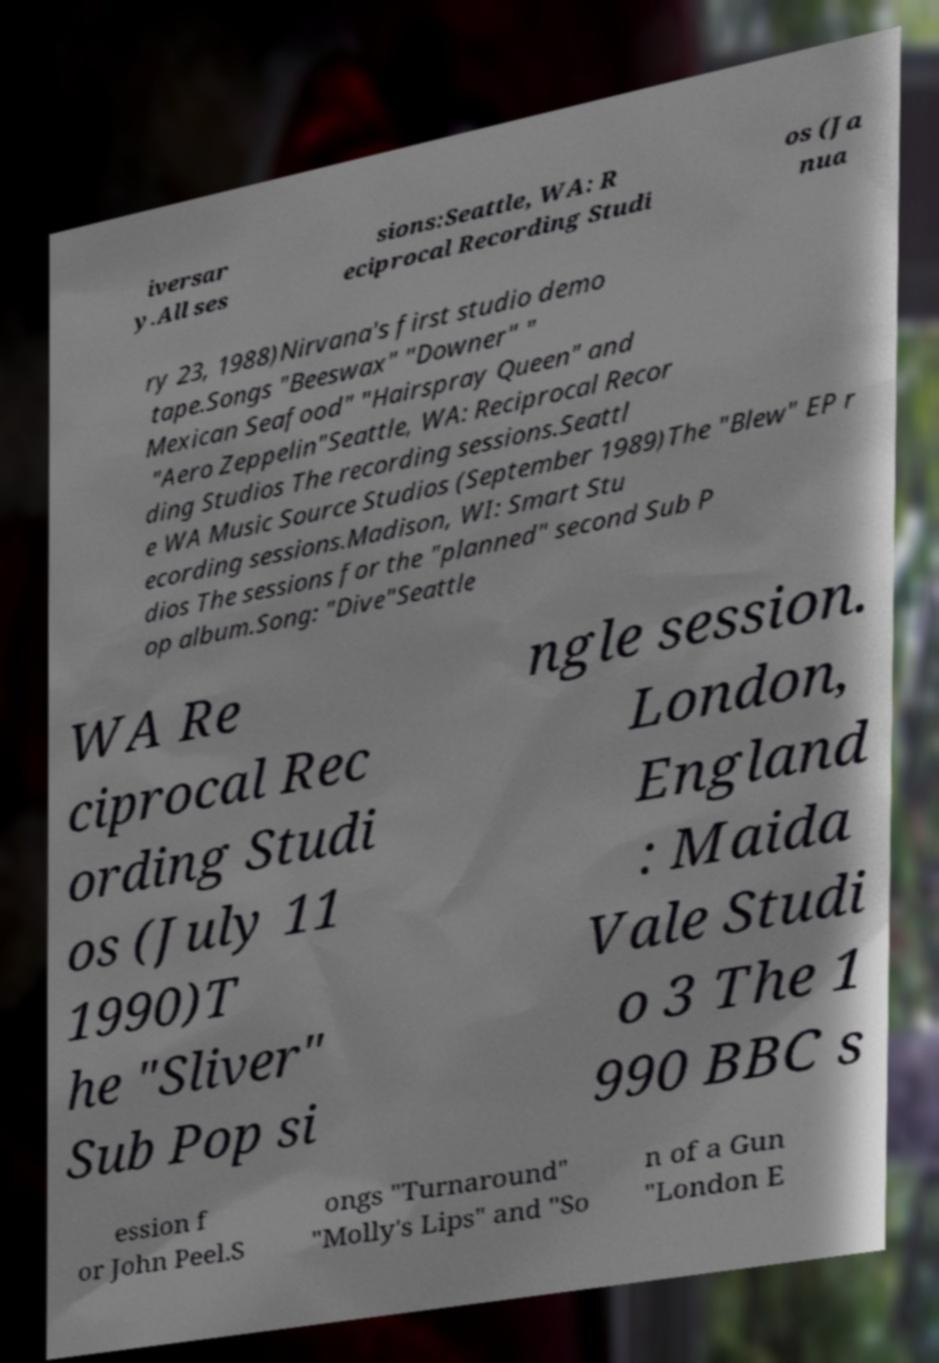I need the written content from this picture converted into text. Can you do that? iversar y.All ses sions:Seattle, WA: R eciprocal Recording Studi os (Ja nua ry 23, 1988)Nirvana's first studio demo tape.Songs "Beeswax" "Downer" " Mexican Seafood" "Hairspray Queen" and "Aero Zeppelin"Seattle, WA: Reciprocal Recor ding Studios The recording sessions.Seattl e WA Music Source Studios (September 1989)The "Blew" EP r ecording sessions.Madison, WI: Smart Stu dios The sessions for the "planned" second Sub P op album.Song: "Dive"Seattle WA Re ciprocal Rec ording Studi os (July 11 1990)T he "Sliver" Sub Pop si ngle session. London, England : Maida Vale Studi o 3 The 1 990 BBC s ession f or John Peel.S ongs "Turnaround" "Molly's Lips" and "So n of a Gun "London E 